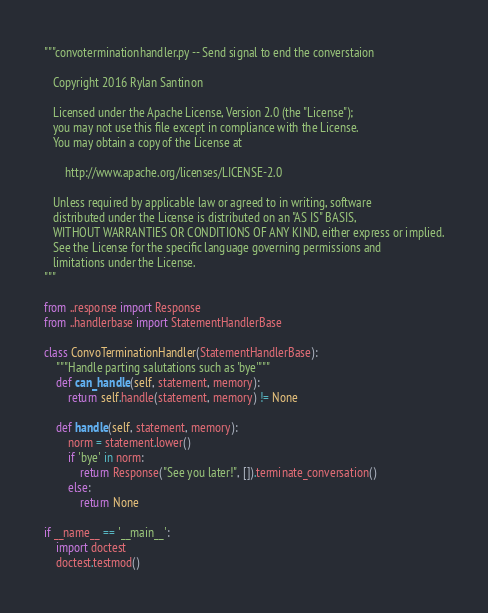<code> <loc_0><loc_0><loc_500><loc_500><_Python_>"""convoterminationhandler.py -- Send signal to end the converstaion

   Copyright 2016 Rylan Santinon

   Licensed under the Apache License, Version 2.0 (the "License");
   you may not use this file except in compliance with the License.
   You may obtain a copy of the License at

       http://www.apache.org/licenses/LICENSE-2.0

   Unless required by applicable law or agreed to in writing, software
   distributed under the License is distributed on an "AS IS" BASIS,
   WITHOUT WARRANTIES OR CONDITIONS OF ANY KIND, either express or implied.
   See the License for the specific language governing permissions and
   limitations under the License.
"""

from ..response import Response
from ..handlerbase import StatementHandlerBase

class ConvoTerminationHandler(StatementHandlerBase):
    """Handle parting salutations such as 'bye'"""
    def can_handle(self, statement, memory):
        return self.handle(statement, memory) != None

    def handle(self, statement, memory):
        norm = statement.lower()
        if 'bye' in norm:
            return Response("See you later!", []).terminate_conversation()
        else:
            return None

if __name__ == '__main__':
    import doctest
    doctest.testmod()
</code> 